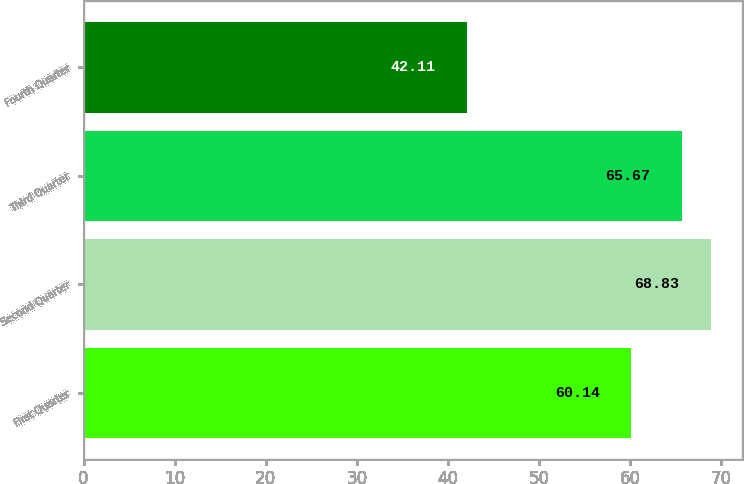Convert chart. <chart><loc_0><loc_0><loc_500><loc_500><bar_chart><fcel>First Quarter<fcel>Second Quarter<fcel>Third Quarter<fcel>Fourth Quarter<nl><fcel>60.14<fcel>68.83<fcel>65.67<fcel>42.11<nl></chart> 